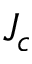Convert formula to latex. <formula><loc_0><loc_0><loc_500><loc_500>J _ { c }</formula> 